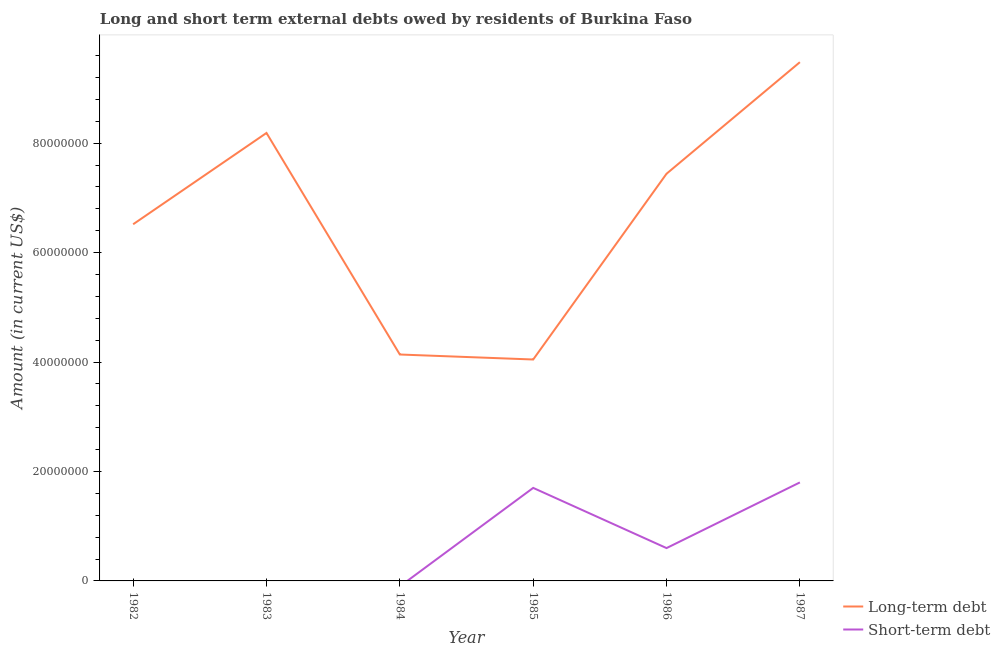Does the line corresponding to long-term debts owed by residents intersect with the line corresponding to short-term debts owed by residents?
Provide a succinct answer. No. Is the number of lines equal to the number of legend labels?
Give a very brief answer. No. What is the long-term debts owed by residents in 1984?
Ensure brevity in your answer.  4.14e+07. Across all years, what is the maximum short-term debts owed by residents?
Provide a succinct answer. 1.80e+07. Across all years, what is the minimum short-term debts owed by residents?
Give a very brief answer. 0. In which year was the short-term debts owed by residents maximum?
Make the answer very short. 1987. What is the total long-term debts owed by residents in the graph?
Make the answer very short. 3.98e+08. What is the difference between the short-term debts owed by residents in 1985 and that in 1986?
Ensure brevity in your answer.  1.10e+07. What is the difference between the long-term debts owed by residents in 1986 and the short-term debts owed by residents in 1985?
Make the answer very short. 5.74e+07. What is the average long-term debts owed by residents per year?
Make the answer very short. 6.63e+07. In the year 1985, what is the difference between the long-term debts owed by residents and short-term debts owed by residents?
Offer a terse response. 2.35e+07. What is the ratio of the long-term debts owed by residents in 1983 to that in 1987?
Offer a very short reply. 0.86. Is the long-term debts owed by residents in 1982 less than that in 1983?
Give a very brief answer. Yes. What is the difference between the highest and the second highest short-term debts owed by residents?
Your answer should be compact. 1.00e+06. What is the difference between the highest and the lowest long-term debts owed by residents?
Your answer should be very brief. 5.43e+07. Is the long-term debts owed by residents strictly greater than the short-term debts owed by residents over the years?
Ensure brevity in your answer.  Yes. Is the long-term debts owed by residents strictly less than the short-term debts owed by residents over the years?
Make the answer very short. No. How many lines are there?
Your answer should be very brief. 2. What is the difference between two consecutive major ticks on the Y-axis?
Ensure brevity in your answer.  2.00e+07. Does the graph contain any zero values?
Ensure brevity in your answer.  Yes. Does the graph contain grids?
Ensure brevity in your answer.  No. How many legend labels are there?
Your answer should be compact. 2. How are the legend labels stacked?
Your answer should be very brief. Vertical. What is the title of the graph?
Keep it short and to the point. Long and short term external debts owed by residents of Burkina Faso. What is the label or title of the Y-axis?
Offer a very short reply. Amount (in current US$). What is the Amount (in current US$) of Long-term debt in 1982?
Your response must be concise. 6.52e+07. What is the Amount (in current US$) of Short-term debt in 1982?
Offer a very short reply. 0. What is the Amount (in current US$) of Long-term debt in 1983?
Offer a terse response. 8.19e+07. What is the Amount (in current US$) in Short-term debt in 1983?
Offer a terse response. 0. What is the Amount (in current US$) of Long-term debt in 1984?
Give a very brief answer. 4.14e+07. What is the Amount (in current US$) in Long-term debt in 1985?
Provide a short and direct response. 4.05e+07. What is the Amount (in current US$) in Short-term debt in 1985?
Your answer should be compact. 1.70e+07. What is the Amount (in current US$) in Long-term debt in 1986?
Provide a succinct answer. 7.44e+07. What is the Amount (in current US$) in Long-term debt in 1987?
Your answer should be very brief. 9.48e+07. What is the Amount (in current US$) in Short-term debt in 1987?
Your response must be concise. 1.80e+07. Across all years, what is the maximum Amount (in current US$) in Long-term debt?
Keep it short and to the point. 9.48e+07. Across all years, what is the maximum Amount (in current US$) of Short-term debt?
Your answer should be very brief. 1.80e+07. Across all years, what is the minimum Amount (in current US$) in Long-term debt?
Offer a very short reply. 4.05e+07. Across all years, what is the minimum Amount (in current US$) in Short-term debt?
Provide a succinct answer. 0. What is the total Amount (in current US$) of Long-term debt in the graph?
Ensure brevity in your answer.  3.98e+08. What is the total Amount (in current US$) of Short-term debt in the graph?
Offer a terse response. 4.10e+07. What is the difference between the Amount (in current US$) in Long-term debt in 1982 and that in 1983?
Your response must be concise. -1.67e+07. What is the difference between the Amount (in current US$) of Long-term debt in 1982 and that in 1984?
Make the answer very short. 2.38e+07. What is the difference between the Amount (in current US$) of Long-term debt in 1982 and that in 1985?
Your response must be concise. 2.47e+07. What is the difference between the Amount (in current US$) in Long-term debt in 1982 and that in 1986?
Give a very brief answer. -9.23e+06. What is the difference between the Amount (in current US$) in Long-term debt in 1982 and that in 1987?
Provide a short and direct response. -2.96e+07. What is the difference between the Amount (in current US$) of Long-term debt in 1983 and that in 1984?
Your answer should be very brief. 4.05e+07. What is the difference between the Amount (in current US$) of Long-term debt in 1983 and that in 1985?
Offer a terse response. 4.14e+07. What is the difference between the Amount (in current US$) in Long-term debt in 1983 and that in 1986?
Make the answer very short. 7.46e+06. What is the difference between the Amount (in current US$) in Long-term debt in 1983 and that in 1987?
Provide a succinct answer. -1.29e+07. What is the difference between the Amount (in current US$) in Long-term debt in 1984 and that in 1985?
Give a very brief answer. 9.12e+05. What is the difference between the Amount (in current US$) in Long-term debt in 1984 and that in 1986?
Keep it short and to the point. -3.30e+07. What is the difference between the Amount (in current US$) in Long-term debt in 1984 and that in 1987?
Offer a terse response. -5.34e+07. What is the difference between the Amount (in current US$) in Long-term debt in 1985 and that in 1986?
Your answer should be compact. -3.39e+07. What is the difference between the Amount (in current US$) of Short-term debt in 1985 and that in 1986?
Ensure brevity in your answer.  1.10e+07. What is the difference between the Amount (in current US$) of Long-term debt in 1985 and that in 1987?
Provide a short and direct response. -5.43e+07. What is the difference between the Amount (in current US$) in Long-term debt in 1986 and that in 1987?
Offer a terse response. -2.04e+07. What is the difference between the Amount (in current US$) of Short-term debt in 1986 and that in 1987?
Give a very brief answer. -1.20e+07. What is the difference between the Amount (in current US$) in Long-term debt in 1982 and the Amount (in current US$) in Short-term debt in 1985?
Your answer should be compact. 4.82e+07. What is the difference between the Amount (in current US$) in Long-term debt in 1982 and the Amount (in current US$) in Short-term debt in 1986?
Your answer should be very brief. 5.92e+07. What is the difference between the Amount (in current US$) of Long-term debt in 1982 and the Amount (in current US$) of Short-term debt in 1987?
Your response must be concise. 4.72e+07. What is the difference between the Amount (in current US$) in Long-term debt in 1983 and the Amount (in current US$) in Short-term debt in 1985?
Give a very brief answer. 6.49e+07. What is the difference between the Amount (in current US$) of Long-term debt in 1983 and the Amount (in current US$) of Short-term debt in 1986?
Give a very brief answer. 7.59e+07. What is the difference between the Amount (in current US$) in Long-term debt in 1983 and the Amount (in current US$) in Short-term debt in 1987?
Your answer should be very brief. 6.39e+07. What is the difference between the Amount (in current US$) of Long-term debt in 1984 and the Amount (in current US$) of Short-term debt in 1985?
Keep it short and to the point. 2.44e+07. What is the difference between the Amount (in current US$) in Long-term debt in 1984 and the Amount (in current US$) in Short-term debt in 1986?
Your response must be concise. 3.54e+07. What is the difference between the Amount (in current US$) of Long-term debt in 1984 and the Amount (in current US$) of Short-term debt in 1987?
Offer a very short reply. 2.34e+07. What is the difference between the Amount (in current US$) of Long-term debt in 1985 and the Amount (in current US$) of Short-term debt in 1986?
Offer a terse response. 3.45e+07. What is the difference between the Amount (in current US$) of Long-term debt in 1985 and the Amount (in current US$) of Short-term debt in 1987?
Offer a terse response. 2.25e+07. What is the difference between the Amount (in current US$) in Long-term debt in 1986 and the Amount (in current US$) in Short-term debt in 1987?
Keep it short and to the point. 5.64e+07. What is the average Amount (in current US$) in Long-term debt per year?
Make the answer very short. 6.63e+07. What is the average Amount (in current US$) in Short-term debt per year?
Make the answer very short. 6.83e+06. In the year 1985, what is the difference between the Amount (in current US$) of Long-term debt and Amount (in current US$) of Short-term debt?
Keep it short and to the point. 2.35e+07. In the year 1986, what is the difference between the Amount (in current US$) of Long-term debt and Amount (in current US$) of Short-term debt?
Your response must be concise. 6.84e+07. In the year 1987, what is the difference between the Amount (in current US$) of Long-term debt and Amount (in current US$) of Short-term debt?
Your response must be concise. 7.68e+07. What is the ratio of the Amount (in current US$) of Long-term debt in 1982 to that in 1983?
Your response must be concise. 0.8. What is the ratio of the Amount (in current US$) of Long-term debt in 1982 to that in 1984?
Offer a very short reply. 1.58. What is the ratio of the Amount (in current US$) in Long-term debt in 1982 to that in 1985?
Provide a succinct answer. 1.61. What is the ratio of the Amount (in current US$) of Long-term debt in 1982 to that in 1986?
Offer a very short reply. 0.88. What is the ratio of the Amount (in current US$) in Long-term debt in 1982 to that in 1987?
Make the answer very short. 0.69. What is the ratio of the Amount (in current US$) of Long-term debt in 1983 to that in 1984?
Make the answer very short. 1.98. What is the ratio of the Amount (in current US$) in Long-term debt in 1983 to that in 1985?
Make the answer very short. 2.02. What is the ratio of the Amount (in current US$) of Long-term debt in 1983 to that in 1986?
Provide a short and direct response. 1.1. What is the ratio of the Amount (in current US$) in Long-term debt in 1983 to that in 1987?
Provide a succinct answer. 0.86. What is the ratio of the Amount (in current US$) of Long-term debt in 1984 to that in 1985?
Offer a terse response. 1.02. What is the ratio of the Amount (in current US$) of Long-term debt in 1984 to that in 1986?
Give a very brief answer. 0.56. What is the ratio of the Amount (in current US$) of Long-term debt in 1984 to that in 1987?
Make the answer very short. 0.44. What is the ratio of the Amount (in current US$) in Long-term debt in 1985 to that in 1986?
Make the answer very short. 0.54. What is the ratio of the Amount (in current US$) in Short-term debt in 1985 to that in 1986?
Your answer should be very brief. 2.83. What is the ratio of the Amount (in current US$) in Long-term debt in 1985 to that in 1987?
Offer a very short reply. 0.43. What is the ratio of the Amount (in current US$) in Short-term debt in 1985 to that in 1987?
Provide a short and direct response. 0.94. What is the ratio of the Amount (in current US$) in Long-term debt in 1986 to that in 1987?
Offer a very short reply. 0.78. What is the difference between the highest and the second highest Amount (in current US$) of Long-term debt?
Your answer should be very brief. 1.29e+07. What is the difference between the highest and the lowest Amount (in current US$) in Long-term debt?
Your response must be concise. 5.43e+07. What is the difference between the highest and the lowest Amount (in current US$) of Short-term debt?
Ensure brevity in your answer.  1.80e+07. 